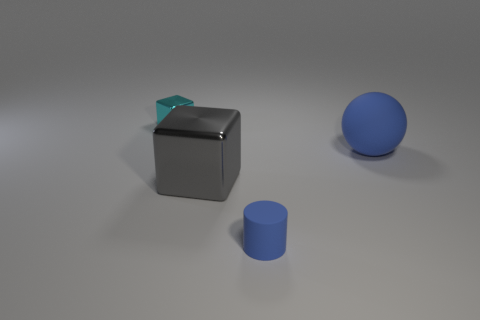Is there anything the positioning of these objects can tell us? The positioning of the cylinder, cube, and sphere appears deliberate, spaced out on what looks like a flat surface. Their distribution allows each object to be distinctly viewed, which is often a technique used in visual studies to understand the properties of shapes and how light interacts with different surfaces and angles. 